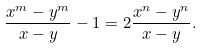Convert formula to latex. <formula><loc_0><loc_0><loc_500><loc_500>\frac { x ^ { m } - y ^ { m } } { x - y } - 1 = 2 \frac { x ^ { n } - y ^ { n } } { x - y } .</formula> 